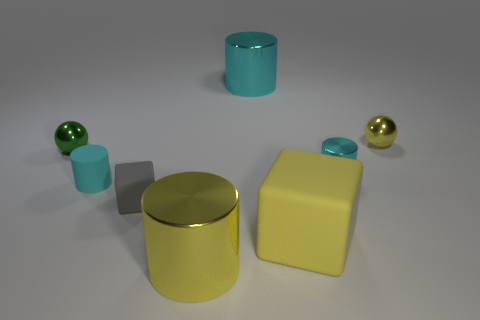How many cyan cylinders must be subtracted to get 1 cyan cylinders? 2 Subtract all red blocks. How many cyan cylinders are left? 3 Subtract all metal cylinders. How many cylinders are left? 1 Add 2 rubber cylinders. How many objects exist? 10 Subtract all gray cubes. How many cubes are left? 1 Add 5 small green objects. How many small green objects are left? 6 Add 3 yellow matte things. How many yellow matte things exist? 4 Subtract 0 cyan blocks. How many objects are left? 8 Subtract all cubes. How many objects are left? 6 Subtract all red cylinders. Subtract all red blocks. How many cylinders are left? 4 